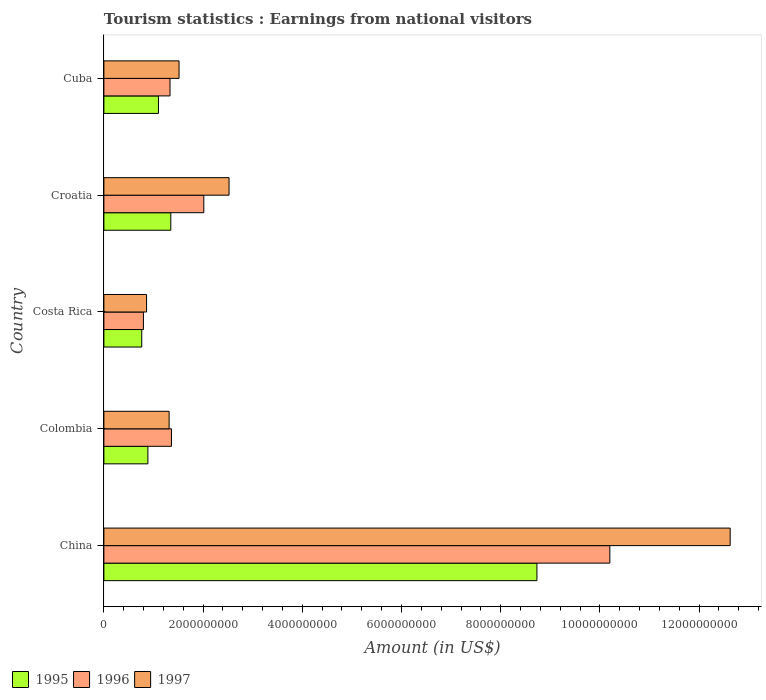How many different coloured bars are there?
Your answer should be very brief. 3. How many groups of bars are there?
Ensure brevity in your answer.  5. Are the number of bars per tick equal to the number of legend labels?
Your answer should be compact. Yes. Are the number of bars on each tick of the Y-axis equal?
Make the answer very short. Yes. What is the label of the 3rd group of bars from the top?
Make the answer very short. Costa Rica. What is the earnings from national visitors in 1996 in Cuba?
Give a very brief answer. 1.33e+09. Across all countries, what is the maximum earnings from national visitors in 1997?
Your answer should be very brief. 1.26e+1. Across all countries, what is the minimum earnings from national visitors in 1995?
Offer a terse response. 7.63e+08. What is the total earnings from national visitors in 1996 in the graph?
Provide a short and direct response. 1.57e+1. What is the difference between the earnings from national visitors in 1997 in Colombia and that in Cuba?
Your answer should be compact. -2.00e+08. What is the difference between the earnings from national visitors in 1997 in Cuba and the earnings from national visitors in 1996 in Colombia?
Offer a terse response. 1.53e+08. What is the average earnings from national visitors in 1995 per country?
Offer a terse response. 2.57e+09. What is the difference between the earnings from national visitors in 1997 and earnings from national visitors in 1996 in Costa Rica?
Make the answer very short. 6.30e+07. What is the ratio of the earnings from national visitors in 1996 in Costa Rica to that in Croatia?
Provide a succinct answer. 0.4. What is the difference between the highest and the second highest earnings from national visitors in 1995?
Your answer should be very brief. 7.38e+09. What is the difference between the highest and the lowest earnings from national visitors in 1997?
Ensure brevity in your answer.  1.18e+1. In how many countries, is the earnings from national visitors in 1996 greater than the average earnings from national visitors in 1996 taken over all countries?
Your response must be concise. 1. How many bars are there?
Your response must be concise. 15. Are all the bars in the graph horizontal?
Your response must be concise. Yes. How many countries are there in the graph?
Offer a very short reply. 5. What is the difference between two consecutive major ticks on the X-axis?
Make the answer very short. 2.00e+09. Does the graph contain grids?
Make the answer very short. No. Where does the legend appear in the graph?
Keep it short and to the point. Bottom left. How many legend labels are there?
Your answer should be very brief. 3. How are the legend labels stacked?
Offer a very short reply. Horizontal. What is the title of the graph?
Provide a succinct answer. Tourism statistics : Earnings from national visitors. What is the label or title of the X-axis?
Your response must be concise. Amount (in US$). What is the label or title of the Y-axis?
Provide a short and direct response. Country. What is the Amount (in US$) in 1995 in China?
Provide a succinct answer. 8.73e+09. What is the Amount (in US$) in 1996 in China?
Make the answer very short. 1.02e+1. What is the Amount (in US$) of 1997 in China?
Your response must be concise. 1.26e+1. What is the Amount (in US$) of 1995 in Colombia?
Make the answer very short. 8.87e+08. What is the Amount (in US$) of 1996 in Colombia?
Provide a succinct answer. 1.36e+09. What is the Amount (in US$) of 1997 in Colombia?
Ensure brevity in your answer.  1.32e+09. What is the Amount (in US$) of 1995 in Costa Rica?
Provide a short and direct response. 7.63e+08. What is the Amount (in US$) of 1996 in Costa Rica?
Keep it short and to the point. 7.97e+08. What is the Amount (in US$) of 1997 in Costa Rica?
Your answer should be compact. 8.60e+08. What is the Amount (in US$) of 1995 in Croatia?
Make the answer very short. 1.35e+09. What is the Amount (in US$) of 1996 in Croatia?
Your answer should be compact. 2.01e+09. What is the Amount (in US$) in 1997 in Croatia?
Your answer should be compact. 2.52e+09. What is the Amount (in US$) in 1995 in Cuba?
Make the answer very short. 1.10e+09. What is the Amount (in US$) in 1996 in Cuba?
Provide a short and direct response. 1.33e+09. What is the Amount (in US$) of 1997 in Cuba?
Offer a very short reply. 1.52e+09. Across all countries, what is the maximum Amount (in US$) in 1995?
Keep it short and to the point. 8.73e+09. Across all countries, what is the maximum Amount (in US$) of 1996?
Keep it short and to the point. 1.02e+1. Across all countries, what is the maximum Amount (in US$) in 1997?
Make the answer very short. 1.26e+1. Across all countries, what is the minimum Amount (in US$) in 1995?
Your response must be concise. 7.63e+08. Across all countries, what is the minimum Amount (in US$) of 1996?
Your answer should be compact. 7.97e+08. Across all countries, what is the minimum Amount (in US$) in 1997?
Provide a short and direct response. 8.60e+08. What is the total Amount (in US$) in 1995 in the graph?
Ensure brevity in your answer.  1.28e+1. What is the total Amount (in US$) of 1996 in the graph?
Your response must be concise. 1.57e+1. What is the total Amount (in US$) in 1997 in the graph?
Keep it short and to the point. 1.88e+1. What is the difference between the Amount (in US$) in 1995 in China and that in Colombia?
Your answer should be very brief. 7.84e+09. What is the difference between the Amount (in US$) in 1996 in China and that in Colombia?
Offer a terse response. 8.84e+09. What is the difference between the Amount (in US$) of 1997 in China and that in Colombia?
Offer a terse response. 1.13e+1. What is the difference between the Amount (in US$) in 1995 in China and that in Costa Rica?
Provide a succinct answer. 7.97e+09. What is the difference between the Amount (in US$) in 1996 in China and that in Costa Rica?
Your answer should be very brief. 9.40e+09. What is the difference between the Amount (in US$) in 1997 in China and that in Costa Rica?
Offer a terse response. 1.18e+1. What is the difference between the Amount (in US$) of 1995 in China and that in Croatia?
Give a very brief answer. 7.38e+09. What is the difference between the Amount (in US$) of 1996 in China and that in Croatia?
Give a very brief answer. 8.19e+09. What is the difference between the Amount (in US$) of 1997 in China and that in Croatia?
Keep it short and to the point. 1.01e+1. What is the difference between the Amount (in US$) in 1995 in China and that in Cuba?
Make the answer very short. 7.63e+09. What is the difference between the Amount (in US$) of 1996 in China and that in Cuba?
Keep it short and to the point. 8.87e+09. What is the difference between the Amount (in US$) of 1997 in China and that in Cuba?
Offer a very short reply. 1.11e+1. What is the difference between the Amount (in US$) in 1995 in Colombia and that in Costa Rica?
Your answer should be very brief. 1.24e+08. What is the difference between the Amount (in US$) of 1996 in Colombia and that in Costa Rica?
Your response must be concise. 5.65e+08. What is the difference between the Amount (in US$) in 1997 in Colombia and that in Costa Rica?
Give a very brief answer. 4.55e+08. What is the difference between the Amount (in US$) in 1995 in Colombia and that in Croatia?
Provide a succinct answer. -4.62e+08. What is the difference between the Amount (in US$) in 1996 in Colombia and that in Croatia?
Offer a very short reply. -6.52e+08. What is the difference between the Amount (in US$) of 1997 in Colombia and that in Croatia?
Your answer should be compact. -1.21e+09. What is the difference between the Amount (in US$) of 1995 in Colombia and that in Cuba?
Offer a very short reply. -2.13e+08. What is the difference between the Amount (in US$) in 1996 in Colombia and that in Cuba?
Your answer should be very brief. 2.90e+07. What is the difference between the Amount (in US$) in 1997 in Colombia and that in Cuba?
Offer a terse response. -2.00e+08. What is the difference between the Amount (in US$) in 1995 in Costa Rica and that in Croatia?
Your response must be concise. -5.86e+08. What is the difference between the Amount (in US$) in 1996 in Costa Rica and that in Croatia?
Offer a very short reply. -1.22e+09. What is the difference between the Amount (in US$) in 1997 in Costa Rica and that in Croatia?
Offer a terse response. -1.66e+09. What is the difference between the Amount (in US$) of 1995 in Costa Rica and that in Cuba?
Your response must be concise. -3.37e+08. What is the difference between the Amount (in US$) in 1996 in Costa Rica and that in Cuba?
Your answer should be compact. -5.36e+08. What is the difference between the Amount (in US$) of 1997 in Costa Rica and that in Cuba?
Your answer should be very brief. -6.55e+08. What is the difference between the Amount (in US$) in 1995 in Croatia and that in Cuba?
Provide a succinct answer. 2.49e+08. What is the difference between the Amount (in US$) of 1996 in Croatia and that in Cuba?
Your answer should be very brief. 6.81e+08. What is the difference between the Amount (in US$) of 1997 in Croatia and that in Cuba?
Offer a very short reply. 1.01e+09. What is the difference between the Amount (in US$) in 1995 in China and the Amount (in US$) in 1996 in Colombia?
Offer a terse response. 7.37e+09. What is the difference between the Amount (in US$) of 1995 in China and the Amount (in US$) of 1997 in Colombia?
Your answer should be compact. 7.42e+09. What is the difference between the Amount (in US$) of 1996 in China and the Amount (in US$) of 1997 in Colombia?
Ensure brevity in your answer.  8.88e+09. What is the difference between the Amount (in US$) in 1995 in China and the Amount (in US$) in 1996 in Costa Rica?
Keep it short and to the point. 7.93e+09. What is the difference between the Amount (in US$) in 1995 in China and the Amount (in US$) in 1997 in Costa Rica?
Keep it short and to the point. 7.87e+09. What is the difference between the Amount (in US$) of 1996 in China and the Amount (in US$) of 1997 in Costa Rica?
Offer a terse response. 9.34e+09. What is the difference between the Amount (in US$) of 1995 in China and the Amount (in US$) of 1996 in Croatia?
Make the answer very short. 6.72e+09. What is the difference between the Amount (in US$) of 1995 in China and the Amount (in US$) of 1997 in Croatia?
Provide a short and direct response. 6.21e+09. What is the difference between the Amount (in US$) of 1996 in China and the Amount (in US$) of 1997 in Croatia?
Offer a very short reply. 7.68e+09. What is the difference between the Amount (in US$) in 1995 in China and the Amount (in US$) in 1996 in Cuba?
Offer a terse response. 7.40e+09. What is the difference between the Amount (in US$) in 1995 in China and the Amount (in US$) in 1997 in Cuba?
Your answer should be very brief. 7.22e+09. What is the difference between the Amount (in US$) in 1996 in China and the Amount (in US$) in 1997 in Cuba?
Keep it short and to the point. 8.68e+09. What is the difference between the Amount (in US$) in 1995 in Colombia and the Amount (in US$) in 1996 in Costa Rica?
Keep it short and to the point. 9.00e+07. What is the difference between the Amount (in US$) of 1995 in Colombia and the Amount (in US$) of 1997 in Costa Rica?
Offer a very short reply. 2.70e+07. What is the difference between the Amount (in US$) in 1996 in Colombia and the Amount (in US$) in 1997 in Costa Rica?
Give a very brief answer. 5.02e+08. What is the difference between the Amount (in US$) in 1995 in Colombia and the Amount (in US$) in 1996 in Croatia?
Offer a terse response. -1.13e+09. What is the difference between the Amount (in US$) of 1995 in Colombia and the Amount (in US$) of 1997 in Croatia?
Keep it short and to the point. -1.64e+09. What is the difference between the Amount (in US$) of 1996 in Colombia and the Amount (in US$) of 1997 in Croatia?
Keep it short and to the point. -1.16e+09. What is the difference between the Amount (in US$) in 1995 in Colombia and the Amount (in US$) in 1996 in Cuba?
Your response must be concise. -4.46e+08. What is the difference between the Amount (in US$) of 1995 in Colombia and the Amount (in US$) of 1997 in Cuba?
Provide a short and direct response. -6.28e+08. What is the difference between the Amount (in US$) of 1996 in Colombia and the Amount (in US$) of 1997 in Cuba?
Ensure brevity in your answer.  -1.53e+08. What is the difference between the Amount (in US$) in 1995 in Costa Rica and the Amount (in US$) in 1996 in Croatia?
Offer a terse response. -1.25e+09. What is the difference between the Amount (in US$) of 1995 in Costa Rica and the Amount (in US$) of 1997 in Croatia?
Keep it short and to the point. -1.76e+09. What is the difference between the Amount (in US$) in 1996 in Costa Rica and the Amount (in US$) in 1997 in Croatia?
Make the answer very short. -1.73e+09. What is the difference between the Amount (in US$) of 1995 in Costa Rica and the Amount (in US$) of 1996 in Cuba?
Ensure brevity in your answer.  -5.70e+08. What is the difference between the Amount (in US$) in 1995 in Costa Rica and the Amount (in US$) in 1997 in Cuba?
Offer a very short reply. -7.52e+08. What is the difference between the Amount (in US$) in 1996 in Costa Rica and the Amount (in US$) in 1997 in Cuba?
Offer a terse response. -7.18e+08. What is the difference between the Amount (in US$) of 1995 in Croatia and the Amount (in US$) of 1996 in Cuba?
Your response must be concise. 1.60e+07. What is the difference between the Amount (in US$) in 1995 in Croatia and the Amount (in US$) in 1997 in Cuba?
Your answer should be very brief. -1.66e+08. What is the difference between the Amount (in US$) of 1996 in Croatia and the Amount (in US$) of 1997 in Cuba?
Offer a very short reply. 4.99e+08. What is the average Amount (in US$) in 1995 per country?
Your answer should be very brief. 2.57e+09. What is the average Amount (in US$) in 1996 per country?
Offer a very short reply. 3.14e+09. What is the average Amount (in US$) of 1997 per country?
Your response must be concise. 3.77e+09. What is the difference between the Amount (in US$) of 1995 and Amount (in US$) of 1996 in China?
Provide a succinct answer. -1.47e+09. What is the difference between the Amount (in US$) of 1995 and Amount (in US$) of 1997 in China?
Give a very brief answer. -3.90e+09. What is the difference between the Amount (in US$) of 1996 and Amount (in US$) of 1997 in China?
Your answer should be compact. -2.43e+09. What is the difference between the Amount (in US$) in 1995 and Amount (in US$) in 1996 in Colombia?
Give a very brief answer. -4.75e+08. What is the difference between the Amount (in US$) of 1995 and Amount (in US$) of 1997 in Colombia?
Give a very brief answer. -4.28e+08. What is the difference between the Amount (in US$) in 1996 and Amount (in US$) in 1997 in Colombia?
Ensure brevity in your answer.  4.70e+07. What is the difference between the Amount (in US$) in 1995 and Amount (in US$) in 1996 in Costa Rica?
Provide a short and direct response. -3.40e+07. What is the difference between the Amount (in US$) of 1995 and Amount (in US$) of 1997 in Costa Rica?
Keep it short and to the point. -9.70e+07. What is the difference between the Amount (in US$) of 1996 and Amount (in US$) of 1997 in Costa Rica?
Keep it short and to the point. -6.30e+07. What is the difference between the Amount (in US$) in 1995 and Amount (in US$) in 1996 in Croatia?
Make the answer very short. -6.65e+08. What is the difference between the Amount (in US$) of 1995 and Amount (in US$) of 1997 in Croatia?
Provide a succinct answer. -1.17e+09. What is the difference between the Amount (in US$) in 1996 and Amount (in US$) in 1997 in Croatia?
Your answer should be compact. -5.09e+08. What is the difference between the Amount (in US$) of 1995 and Amount (in US$) of 1996 in Cuba?
Make the answer very short. -2.33e+08. What is the difference between the Amount (in US$) in 1995 and Amount (in US$) in 1997 in Cuba?
Your response must be concise. -4.15e+08. What is the difference between the Amount (in US$) in 1996 and Amount (in US$) in 1997 in Cuba?
Give a very brief answer. -1.82e+08. What is the ratio of the Amount (in US$) in 1995 in China to that in Colombia?
Offer a terse response. 9.84. What is the ratio of the Amount (in US$) of 1996 in China to that in Colombia?
Ensure brevity in your answer.  7.49. What is the ratio of the Amount (in US$) in 1997 in China to that in Colombia?
Make the answer very short. 9.6. What is the ratio of the Amount (in US$) in 1995 in China to that in Costa Rica?
Provide a short and direct response. 11.44. What is the ratio of the Amount (in US$) in 1996 in China to that in Costa Rica?
Provide a succinct answer. 12.8. What is the ratio of the Amount (in US$) in 1997 in China to that in Costa Rica?
Offer a terse response. 14.68. What is the ratio of the Amount (in US$) in 1995 in China to that in Croatia?
Your answer should be very brief. 6.47. What is the ratio of the Amount (in US$) of 1996 in China to that in Croatia?
Offer a terse response. 5.06. What is the ratio of the Amount (in US$) of 1997 in China to that in Croatia?
Make the answer very short. 5. What is the ratio of the Amount (in US$) of 1995 in China to that in Cuba?
Offer a terse response. 7.94. What is the ratio of the Amount (in US$) of 1996 in China to that in Cuba?
Your answer should be very brief. 7.65. What is the ratio of the Amount (in US$) in 1997 in China to that in Cuba?
Ensure brevity in your answer.  8.33. What is the ratio of the Amount (in US$) in 1995 in Colombia to that in Costa Rica?
Your answer should be very brief. 1.16. What is the ratio of the Amount (in US$) of 1996 in Colombia to that in Costa Rica?
Keep it short and to the point. 1.71. What is the ratio of the Amount (in US$) in 1997 in Colombia to that in Costa Rica?
Provide a short and direct response. 1.53. What is the ratio of the Amount (in US$) of 1995 in Colombia to that in Croatia?
Provide a succinct answer. 0.66. What is the ratio of the Amount (in US$) in 1996 in Colombia to that in Croatia?
Your answer should be very brief. 0.68. What is the ratio of the Amount (in US$) in 1997 in Colombia to that in Croatia?
Offer a terse response. 0.52. What is the ratio of the Amount (in US$) in 1995 in Colombia to that in Cuba?
Offer a terse response. 0.81. What is the ratio of the Amount (in US$) in 1996 in Colombia to that in Cuba?
Offer a terse response. 1.02. What is the ratio of the Amount (in US$) in 1997 in Colombia to that in Cuba?
Provide a succinct answer. 0.87. What is the ratio of the Amount (in US$) in 1995 in Costa Rica to that in Croatia?
Make the answer very short. 0.57. What is the ratio of the Amount (in US$) in 1996 in Costa Rica to that in Croatia?
Your answer should be very brief. 0.4. What is the ratio of the Amount (in US$) of 1997 in Costa Rica to that in Croatia?
Keep it short and to the point. 0.34. What is the ratio of the Amount (in US$) in 1995 in Costa Rica to that in Cuba?
Provide a short and direct response. 0.69. What is the ratio of the Amount (in US$) in 1996 in Costa Rica to that in Cuba?
Provide a short and direct response. 0.6. What is the ratio of the Amount (in US$) of 1997 in Costa Rica to that in Cuba?
Offer a very short reply. 0.57. What is the ratio of the Amount (in US$) of 1995 in Croatia to that in Cuba?
Make the answer very short. 1.23. What is the ratio of the Amount (in US$) of 1996 in Croatia to that in Cuba?
Provide a short and direct response. 1.51. What is the ratio of the Amount (in US$) of 1997 in Croatia to that in Cuba?
Your answer should be very brief. 1.67. What is the difference between the highest and the second highest Amount (in US$) in 1995?
Offer a very short reply. 7.38e+09. What is the difference between the highest and the second highest Amount (in US$) in 1996?
Offer a very short reply. 8.19e+09. What is the difference between the highest and the second highest Amount (in US$) in 1997?
Offer a very short reply. 1.01e+1. What is the difference between the highest and the lowest Amount (in US$) in 1995?
Your answer should be very brief. 7.97e+09. What is the difference between the highest and the lowest Amount (in US$) in 1996?
Ensure brevity in your answer.  9.40e+09. What is the difference between the highest and the lowest Amount (in US$) in 1997?
Ensure brevity in your answer.  1.18e+1. 